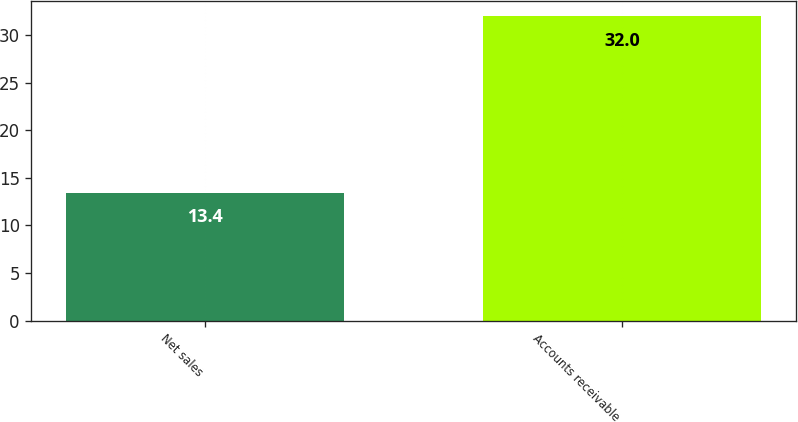<chart> <loc_0><loc_0><loc_500><loc_500><bar_chart><fcel>Net sales<fcel>Accounts receivable<nl><fcel>13.4<fcel>32<nl></chart> 